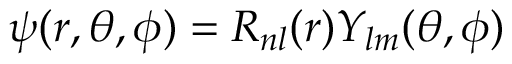Convert formula to latex. <formula><loc_0><loc_0><loc_500><loc_500>\psi ( r , \theta , \phi ) = R _ { n l } ( r ) Y _ { l m } ( \theta , \phi )</formula> 